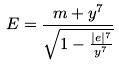<formula> <loc_0><loc_0><loc_500><loc_500>E = \frac { m + y ^ { 7 } } { \sqrt { 1 - \frac { | e | ^ { 7 } } { y ^ { 7 } } } }</formula> 